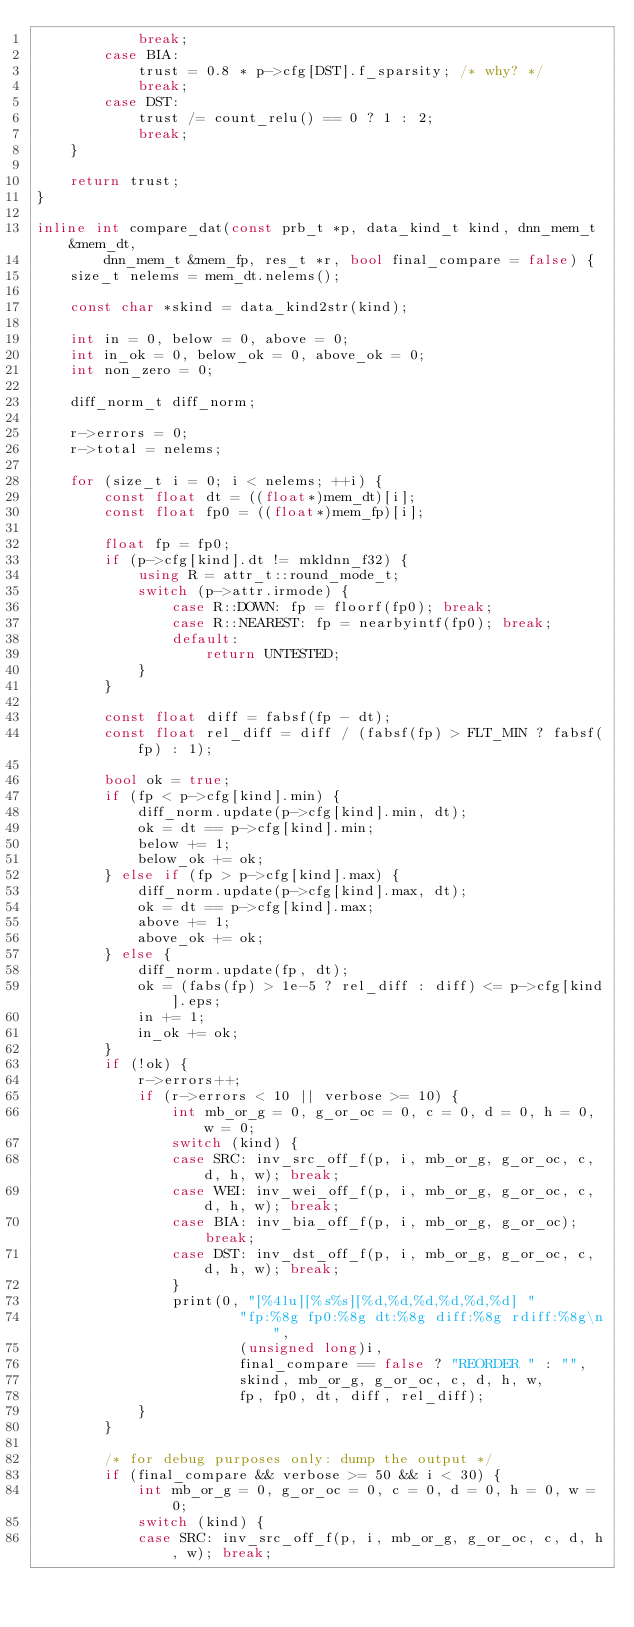Convert code to text. <code><loc_0><loc_0><loc_500><loc_500><_C++_>            break;
        case BIA:
            trust = 0.8 * p->cfg[DST].f_sparsity; /* why? */
            break;
        case DST:
            trust /= count_relu() == 0 ? 1 : 2;
            break;
    }

    return trust;
}

inline int compare_dat(const prb_t *p, data_kind_t kind, dnn_mem_t &mem_dt,
        dnn_mem_t &mem_fp, res_t *r, bool final_compare = false) {
    size_t nelems = mem_dt.nelems();

    const char *skind = data_kind2str(kind);

    int in = 0, below = 0, above = 0;
    int in_ok = 0, below_ok = 0, above_ok = 0;
    int non_zero = 0;

    diff_norm_t diff_norm;

    r->errors = 0;
    r->total = nelems;

    for (size_t i = 0; i < nelems; ++i) {
        const float dt = ((float*)mem_dt)[i];
        const float fp0 = ((float*)mem_fp)[i];

        float fp = fp0;
        if (p->cfg[kind].dt != mkldnn_f32) {
            using R = attr_t::round_mode_t;
            switch (p->attr.irmode) {
                case R::DOWN: fp = floorf(fp0); break;
                case R::NEAREST: fp = nearbyintf(fp0); break;
                default:
                    return UNTESTED;
            }
        }

        const float diff = fabsf(fp - dt);
        const float rel_diff = diff / (fabsf(fp) > FLT_MIN ? fabsf(fp) : 1);

        bool ok = true;
        if (fp < p->cfg[kind].min) {
            diff_norm.update(p->cfg[kind].min, dt);
            ok = dt == p->cfg[kind].min;
            below += 1;
            below_ok += ok;
        } else if (fp > p->cfg[kind].max) {
            diff_norm.update(p->cfg[kind].max, dt);
            ok = dt == p->cfg[kind].max;
            above += 1;
            above_ok += ok;
        } else {
            diff_norm.update(fp, dt);
            ok = (fabs(fp) > 1e-5 ? rel_diff : diff) <= p->cfg[kind].eps;
            in += 1;
            in_ok += ok;
        }
        if (!ok) {
            r->errors++;
            if (r->errors < 10 || verbose >= 10) {
                int mb_or_g = 0, g_or_oc = 0, c = 0, d = 0, h = 0, w = 0;
                switch (kind) {
                case SRC: inv_src_off_f(p, i, mb_or_g, g_or_oc, c, d, h, w); break;
                case WEI: inv_wei_off_f(p, i, mb_or_g, g_or_oc, c, d, h, w); break;
                case BIA: inv_bia_off_f(p, i, mb_or_g, g_or_oc); break;
                case DST: inv_dst_off_f(p, i, mb_or_g, g_or_oc, c, d, h, w); break;
                }
                print(0, "[%4lu][%s%s][%d,%d,%d,%d,%d,%d] "
                        "fp:%8g fp0:%8g dt:%8g diff:%8g rdiff:%8g\n",
                        (unsigned long)i,
                        final_compare == false ? "REORDER " : "",
                        skind, mb_or_g, g_or_oc, c, d, h, w,
                        fp, fp0, dt, diff, rel_diff);
            }
        }

        /* for debug purposes only: dump the output */
        if (final_compare && verbose >= 50 && i < 30) {
            int mb_or_g = 0, g_or_oc = 0, c = 0, d = 0, h = 0, w = 0;
            switch (kind) {
            case SRC: inv_src_off_f(p, i, mb_or_g, g_or_oc, c, d, h, w); break;</code> 